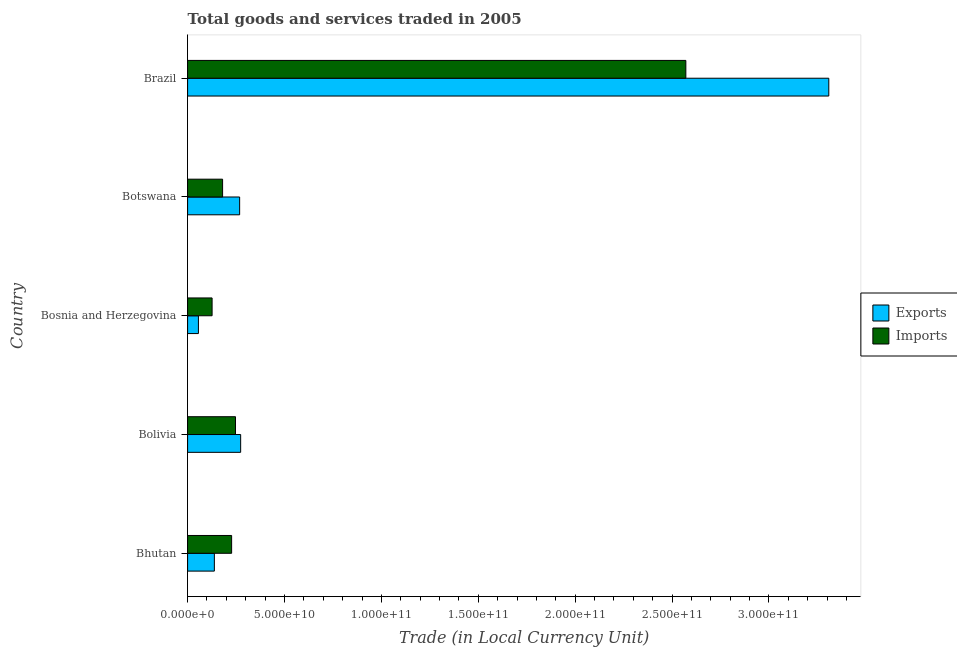How many different coloured bars are there?
Your answer should be compact. 2. Are the number of bars per tick equal to the number of legend labels?
Provide a short and direct response. Yes. Are the number of bars on each tick of the Y-axis equal?
Your answer should be very brief. Yes. How many bars are there on the 2nd tick from the bottom?
Ensure brevity in your answer.  2. What is the label of the 3rd group of bars from the top?
Give a very brief answer. Bosnia and Herzegovina. What is the export of goods and services in Bhutan?
Your answer should be compact. 1.38e+1. Across all countries, what is the maximum imports of goods and services?
Keep it short and to the point. 2.57e+11. Across all countries, what is the minimum imports of goods and services?
Your answer should be very brief. 1.26e+1. In which country was the export of goods and services minimum?
Keep it short and to the point. Bosnia and Herzegovina. What is the total imports of goods and services in the graph?
Offer a terse response. 3.35e+11. What is the difference between the export of goods and services in Bhutan and that in Botswana?
Give a very brief answer. -1.30e+1. What is the difference between the imports of goods and services in Bhutan and the export of goods and services in Bosnia and Herzegovina?
Keep it short and to the point. 1.71e+1. What is the average export of goods and services per country?
Provide a succinct answer. 8.09e+1. What is the difference between the imports of goods and services and export of goods and services in Bolivia?
Make the answer very short. -2.66e+09. In how many countries, is the imports of goods and services greater than 10000000000 LCU?
Provide a succinct answer. 5. What is the ratio of the imports of goods and services in Bolivia to that in Brazil?
Offer a very short reply. 0.1. Is the difference between the imports of goods and services in Bolivia and Botswana greater than the difference between the export of goods and services in Bolivia and Botswana?
Your answer should be compact. Yes. What is the difference between the highest and the second highest export of goods and services?
Ensure brevity in your answer.  3.03e+11. What is the difference between the highest and the lowest export of goods and services?
Give a very brief answer. 3.25e+11. Is the sum of the export of goods and services in Bhutan and Bolivia greater than the maximum imports of goods and services across all countries?
Offer a terse response. No. What does the 2nd bar from the top in Brazil represents?
Make the answer very short. Exports. What does the 1st bar from the bottom in Botswana represents?
Offer a very short reply. Exports. How many bars are there?
Provide a short and direct response. 10. Are the values on the major ticks of X-axis written in scientific E-notation?
Give a very brief answer. Yes. Does the graph contain grids?
Ensure brevity in your answer.  No. Where does the legend appear in the graph?
Your answer should be compact. Center right. How many legend labels are there?
Give a very brief answer. 2. How are the legend labels stacked?
Offer a terse response. Vertical. What is the title of the graph?
Your answer should be very brief. Total goods and services traded in 2005. What is the label or title of the X-axis?
Your answer should be very brief. Trade (in Local Currency Unit). What is the label or title of the Y-axis?
Provide a short and direct response. Country. What is the Trade (in Local Currency Unit) in Exports in Bhutan?
Provide a short and direct response. 1.38e+1. What is the Trade (in Local Currency Unit) in Imports in Bhutan?
Make the answer very short. 2.27e+1. What is the Trade (in Local Currency Unit) in Exports in Bolivia?
Your answer should be compact. 2.74e+1. What is the Trade (in Local Currency Unit) in Imports in Bolivia?
Your answer should be compact. 2.47e+1. What is the Trade (in Local Currency Unit) in Exports in Bosnia and Herzegovina?
Give a very brief answer. 5.58e+09. What is the Trade (in Local Currency Unit) in Imports in Bosnia and Herzegovina?
Offer a very short reply. 1.26e+1. What is the Trade (in Local Currency Unit) in Exports in Botswana?
Your answer should be very brief. 2.69e+1. What is the Trade (in Local Currency Unit) of Imports in Botswana?
Offer a very short reply. 1.81e+1. What is the Trade (in Local Currency Unit) in Exports in Brazil?
Keep it short and to the point. 3.31e+11. What is the Trade (in Local Currency Unit) of Imports in Brazil?
Your answer should be compact. 2.57e+11. Across all countries, what is the maximum Trade (in Local Currency Unit) of Exports?
Your answer should be compact. 3.31e+11. Across all countries, what is the maximum Trade (in Local Currency Unit) in Imports?
Offer a very short reply. 2.57e+11. Across all countries, what is the minimum Trade (in Local Currency Unit) in Exports?
Your answer should be very brief. 5.58e+09. Across all countries, what is the minimum Trade (in Local Currency Unit) in Imports?
Give a very brief answer. 1.26e+1. What is the total Trade (in Local Currency Unit) of Exports in the graph?
Provide a short and direct response. 4.05e+11. What is the total Trade (in Local Currency Unit) of Imports in the graph?
Your answer should be very brief. 3.35e+11. What is the difference between the Trade (in Local Currency Unit) in Exports in Bhutan and that in Bolivia?
Provide a short and direct response. -1.36e+1. What is the difference between the Trade (in Local Currency Unit) of Imports in Bhutan and that in Bolivia?
Your answer should be compact. -2.00e+09. What is the difference between the Trade (in Local Currency Unit) of Exports in Bhutan and that in Bosnia and Herzegovina?
Your response must be concise. 8.23e+09. What is the difference between the Trade (in Local Currency Unit) in Imports in Bhutan and that in Bosnia and Herzegovina?
Give a very brief answer. 1.01e+1. What is the difference between the Trade (in Local Currency Unit) in Exports in Bhutan and that in Botswana?
Ensure brevity in your answer.  -1.30e+1. What is the difference between the Trade (in Local Currency Unit) of Imports in Bhutan and that in Botswana?
Your answer should be compact. 4.67e+09. What is the difference between the Trade (in Local Currency Unit) in Exports in Bhutan and that in Brazil?
Make the answer very short. -3.17e+11. What is the difference between the Trade (in Local Currency Unit) in Imports in Bhutan and that in Brazil?
Give a very brief answer. -2.34e+11. What is the difference between the Trade (in Local Currency Unit) of Exports in Bolivia and that in Bosnia and Herzegovina?
Ensure brevity in your answer.  2.18e+1. What is the difference between the Trade (in Local Currency Unit) in Imports in Bolivia and that in Bosnia and Herzegovina?
Offer a terse response. 1.21e+1. What is the difference between the Trade (in Local Currency Unit) in Exports in Bolivia and that in Botswana?
Offer a terse response. 5.21e+08. What is the difference between the Trade (in Local Currency Unit) in Imports in Bolivia and that in Botswana?
Keep it short and to the point. 6.66e+09. What is the difference between the Trade (in Local Currency Unit) in Exports in Bolivia and that in Brazil?
Provide a succinct answer. -3.03e+11. What is the difference between the Trade (in Local Currency Unit) of Imports in Bolivia and that in Brazil?
Offer a terse response. -2.32e+11. What is the difference between the Trade (in Local Currency Unit) of Exports in Bosnia and Herzegovina and that in Botswana?
Make the answer very short. -2.13e+1. What is the difference between the Trade (in Local Currency Unit) of Imports in Bosnia and Herzegovina and that in Botswana?
Your answer should be very brief. -5.41e+09. What is the difference between the Trade (in Local Currency Unit) of Exports in Bosnia and Herzegovina and that in Brazil?
Ensure brevity in your answer.  -3.25e+11. What is the difference between the Trade (in Local Currency Unit) in Imports in Bosnia and Herzegovina and that in Brazil?
Offer a very short reply. -2.44e+11. What is the difference between the Trade (in Local Currency Unit) of Exports in Botswana and that in Brazil?
Provide a short and direct response. -3.04e+11. What is the difference between the Trade (in Local Currency Unit) in Imports in Botswana and that in Brazil?
Make the answer very short. -2.39e+11. What is the difference between the Trade (in Local Currency Unit) of Exports in Bhutan and the Trade (in Local Currency Unit) of Imports in Bolivia?
Make the answer very short. -1.09e+1. What is the difference between the Trade (in Local Currency Unit) in Exports in Bhutan and the Trade (in Local Currency Unit) in Imports in Bosnia and Herzegovina?
Your response must be concise. 1.17e+09. What is the difference between the Trade (in Local Currency Unit) in Exports in Bhutan and the Trade (in Local Currency Unit) in Imports in Botswana?
Your answer should be very brief. -4.25e+09. What is the difference between the Trade (in Local Currency Unit) of Exports in Bhutan and the Trade (in Local Currency Unit) of Imports in Brazil?
Make the answer very short. -2.43e+11. What is the difference between the Trade (in Local Currency Unit) in Exports in Bolivia and the Trade (in Local Currency Unit) in Imports in Bosnia and Herzegovina?
Ensure brevity in your answer.  1.47e+1. What is the difference between the Trade (in Local Currency Unit) of Exports in Bolivia and the Trade (in Local Currency Unit) of Imports in Botswana?
Provide a short and direct response. 9.32e+09. What is the difference between the Trade (in Local Currency Unit) in Exports in Bolivia and the Trade (in Local Currency Unit) in Imports in Brazil?
Give a very brief answer. -2.30e+11. What is the difference between the Trade (in Local Currency Unit) in Exports in Bosnia and Herzegovina and the Trade (in Local Currency Unit) in Imports in Botswana?
Provide a succinct answer. -1.25e+1. What is the difference between the Trade (in Local Currency Unit) of Exports in Bosnia and Herzegovina and the Trade (in Local Currency Unit) of Imports in Brazil?
Your answer should be very brief. -2.52e+11. What is the difference between the Trade (in Local Currency Unit) in Exports in Botswana and the Trade (in Local Currency Unit) in Imports in Brazil?
Offer a terse response. -2.30e+11. What is the average Trade (in Local Currency Unit) in Exports per country?
Offer a terse response. 8.09e+1. What is the average Trade (in Local Currency Unit) of Imports per country?
Offer a very short reply. 6.71e+1. What is the difference between the Trade (in Local Currency Unit) in Exports and Trade (in Local Currency Unit) in Imports in Bhutan?
Provide a short and direct response. -8.91e+09. What is the difference between the Trade (in Local Currency Unit) in Exports and Trade (in Local Currency Unit) in Imports in Bolivia?
Make the answer very short. 2.66e+09. What is the difference between the Trade (in Local Currency Unit) in Exports and Trade (in Local Currency Unit) in Imports in Bosnia and Herzegovina?
Offer a very short reply. -7.06e+09. What is the difference between the Trade (in Local Currency Unit) in Exports and Trade (in Local Currency Unit) in Imports in Botswana?
Your response must be concise. 8.80e+09. What is the difference between the Trade (in Local Currency Unit) of Exports and Trade (in Local Currency Unit) of Imports in Brazil?
Offer a very short reply. 7.38e+1. What is the ratio of the Trade (in Local Currency Unit) in Exports in Bhutan to that in Bolivia?
Your answer should be compact. 0.5. What is the ratio of the Trade (in Local Currency Unit) in Imports in Bhutan to that in Bolivia?
Ensure brevity in your answer.  0.92. What is the ratio of the Trade (in Local Currency Unit) of Exports in Bhutan to that in Bosnia and Herzegovina?
Offer a very short reply. 2.47. What is the ratio of the Trade (in Local Currency Unit) of Imports in Bhutan to that in Bosnia and Herzegovina?
Offer a very short reply. 1.8. What is the ratio of the Trade (in Local Currency Unit) of Exports in Bhutan to that in Botswana?
Your answer should be compact. 0.51. What is the ratio of the Trade (in Local Currency Unit) in Imports in Bhutan to that in Botswana?
Your response must be concise. 1.26. What is the ratio of the Trade (in Local Currency Unit) of Exports in Bhutan to that in Brazil?
Your answer should be very brief. 0.04. What is the ratio of the Trade (in Local Currency Unit) in Imports in Bhutan to that in Brazil?
Provide a succinct answer. 0.09. What is the ratio of the Trade (in Local Currency Unit) of Exports in Bolivia to that in Bosnia and Herzegovina?
Offer a very short reply. 4.9. What is the ratio of the Trade (in Local Currency Unit) in Imports in Bolivia to that in Bosnia and Herzegovina?
Ensure brevity in your answer.  1.96. What is the ratio of the Trade (in Local Currency Unit) in Exports in Bolivia to that in Botswana?
Offer a very short reply. 1.02. What is the ratio of the Trade (in Local Currency Unit) of Imports in Bolivia to that in Botswana?
Offer a very short reply. 1.37. What is the ratio of the Trade (in Local Currency Unit) of Exports in Bolivia to that in Brazil?
Offer a very short reply. 0.08. What is the ratio of the Trade (in Local Currency Unit) of Imports in Bolivia to that in Brazil?
Your answer should be very brief. 0.1. What is the ratio of the Trade (in Local Currency Unit) in Exports in Bosnia and Herzegovina to that in Botswana?
Provide a short and direct response. 0.21. What is the ratio of the Trade (in Local Currency Unit) in Imports in Bosnia and Herzegovina to that in Botswana?
Make the answer very short. 0.7. What is the ratio of the Trade (in Local Currency Unit) in Exports in Bosnia and Herzegovina to that in Brazil?
Offer a very short reply. 0.02. What is the ratio of the Trade (in Local Currency Unit) of Imports in Bosnia and Herzegovina to that in Brazil?
Your answer should be very brief. 0.05. What is the ratio of the Trade (in Local Currency Unit) in Exports in Botswana to that in Brazil?
Provide a short and direct response. 0.08. What is the ratio of the Trade (in Local Currency Unit) of Imports in Botswana to that in Brazil?
Your answer should be very brief. 0.07. What is the difference between the highest and the second highest Trade (in Local Currency Unit) in Exports?
Ensure brevity in your answer.  3.03e+11. What is the difference between the highest and the second highest Trade (in Local Currency Unit) of Imports?
Your answer should be compact. 2.32e+11. What is the difference between the highest and the lowest Trade (in Local Currency Unit) in Exports?
Provide a short and direct response. 3.25e+11. What is the difference between the highest and the lowest Trade (in Local Currency Unit) in Imports?
Your answer should be compact. 2.44e+11. 